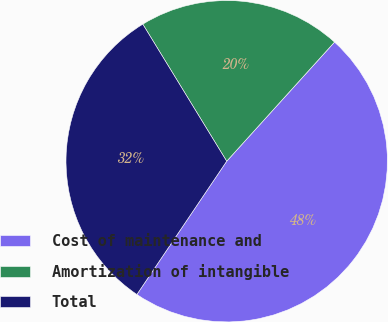<chart> <loc_0><loc_0><loc_500><loc_500><pie_chart><fcel>Cost of maintenance and<fcel>Amortization of intangible<fcel>Total<nl><fcel>47.73%<fcel>20.45%<fcel>31.82%<nl></chart> 